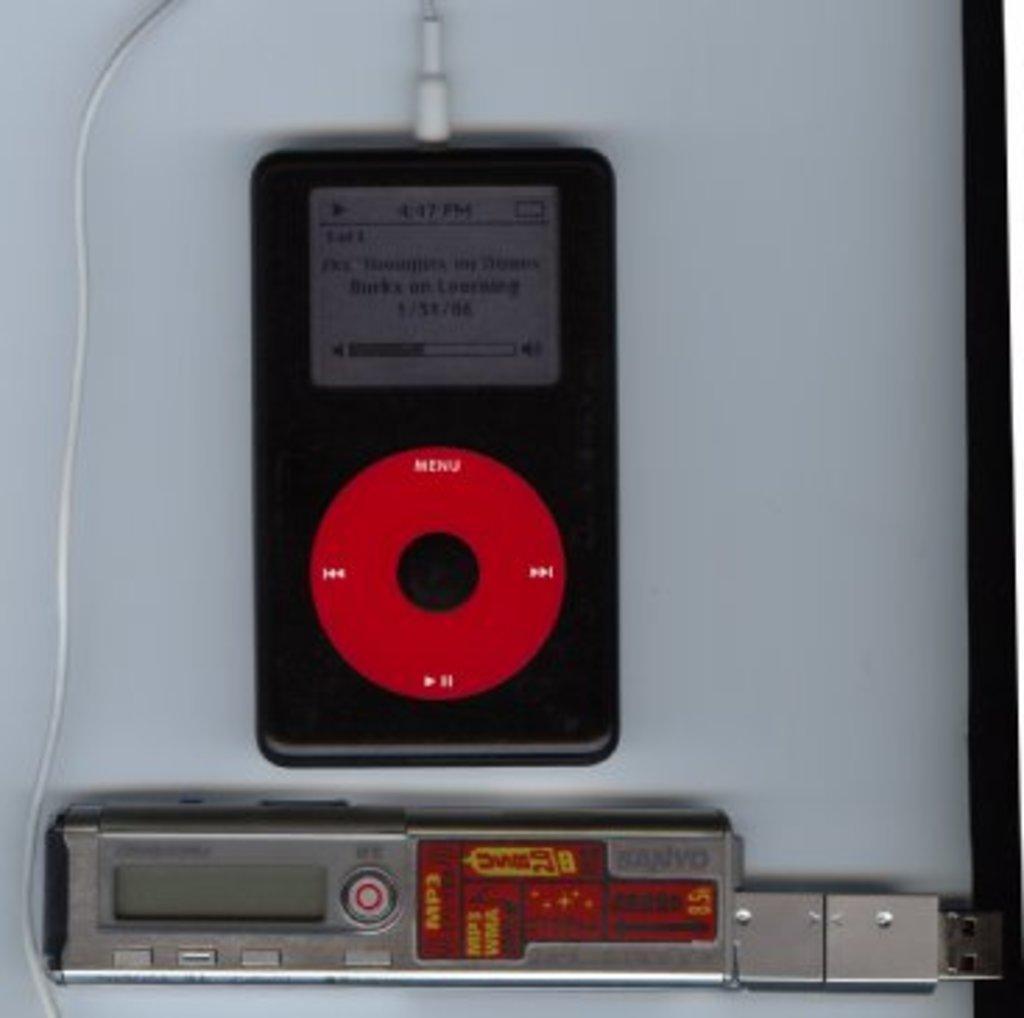Describe this image in one or two sentences. In the picture we can see electronic gadget and a wire is plugged in and there is some other item on floor. 